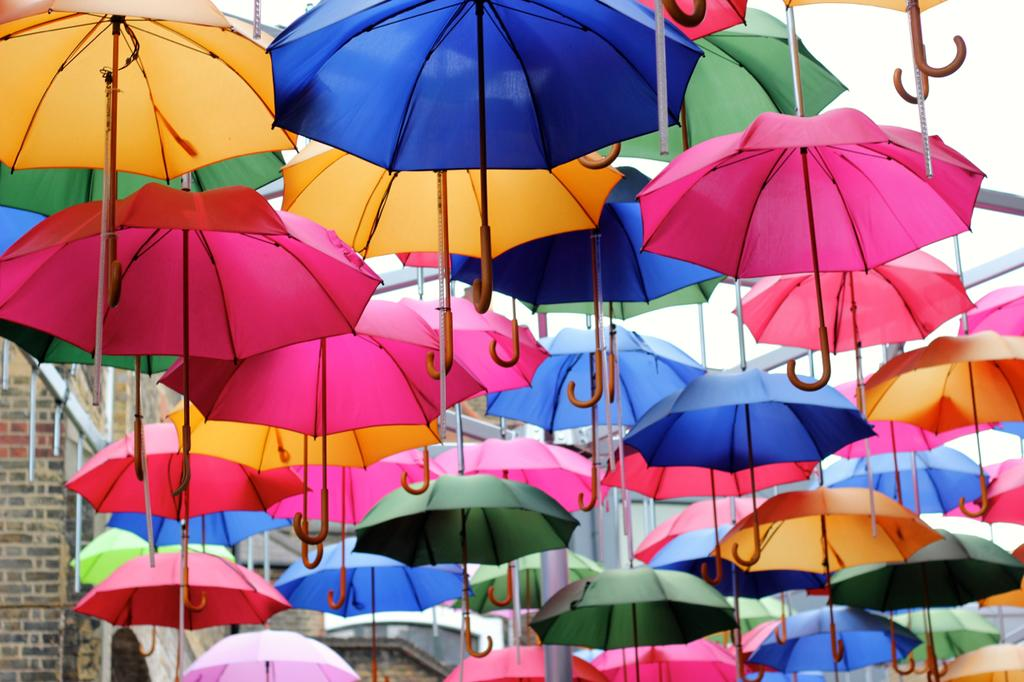What objects are present in the image? There are umbrellas in the image. What can be seen in the background of the image? There is a building in the background of the image. What type of grape is being used as a prop in the image? There is no grape present in the image; it features umbrellas and a building in the background. 